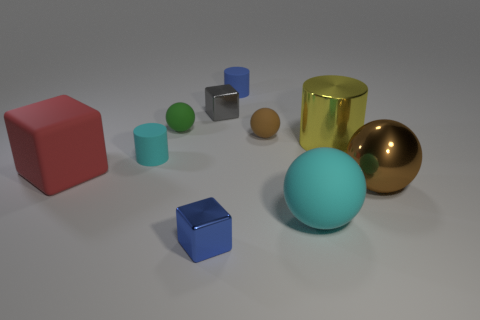There is a big yellow cylinder behind the cyan rubber object that is left of the small gray metal block; how many small blue metallic things are on the right side of it?
Your answer should be very brief. 0. There is a gray metal thing; is its shape the same as the thing that is behind the gray block?
Offer a very short reply. No. There is a block that is to the right of the large red thing and in front of the tiny brown sphere; what is its color?
Give a very brief answer. Blue. What material is the blue object that is on the left side of the rubber cylinder to the right of the blue object that is to the left of the small blue cylinder made of?
Give a very brief answer. Metal. What is the material of the big yellow cylinder?
Your response must be concise. Metal. There is a red matte object that is the same shape as the gray shiny thing; what is its size?
Offer a very short reply. Large. Do the big rubber block and the shiny cylinder have the same color?
Ensure brevity in your answer.  No. What number of other objects are the same material as the small cyan thing?
Ensure brevity in your answer.  5. Are there an equal number of cyan cylinders that are to the right of the big cylinder and yellow metallic cylinders?
Keep it short and to the point. No. Do the cyan object on the right side of the blue cylinder and the big brown object have the same size?
Your response must be concise. Yes. 